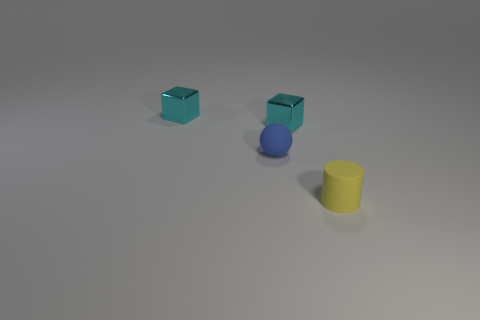Subtract all cylinders. How many objects are left? 3 Add 1 big matte blocks. How many objects exist? 5 Subtract all small blue things. Subtract all yellow matte objects. How many objects are left? 2 Add 1 small cyan metallic objects. How many small cyan metallic objects are left? 3 Add 1 tiny cylinders. How many tiny cylinders exist? 2 Subtract 1 cyan cubes. How many objects are left? 3 